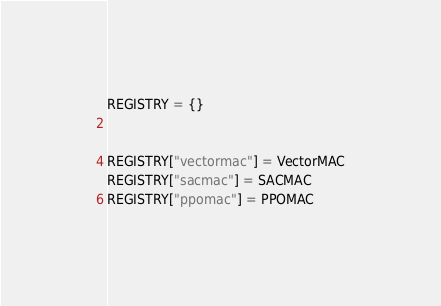<code> <loc_0><loc_0><loc_500><loc_500><_Python_>REGISTRY = {}


REGISTRY["vectormac"] = VectorMAC
REGISTRY["sacmac"] = SACMAC
REGISTRY["ppomac"] = PPOMAC
</code> 